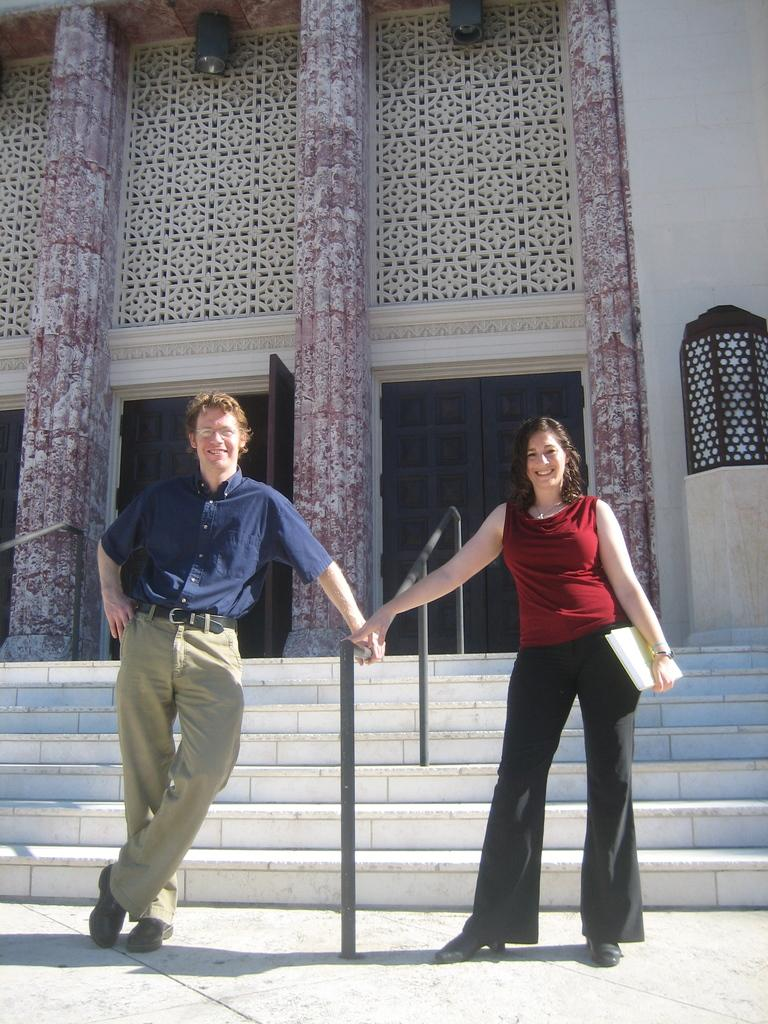How many people are present in the image? There are two people, a man and a woman, present in the image. What are the man and woman doing in the image? Both the man and woman are on the ground. What is the woman holding in the image? The woman is holding a book in the image. What can be seen in the background of the image? There is a building, steps, and railings in the background of the image. What type of honey is the man using to weigh himself in the image? There is no honey or weighing activity present in the image. What nation is the woman representing in the image? There is no indication of a specific nation or representation in the image. 